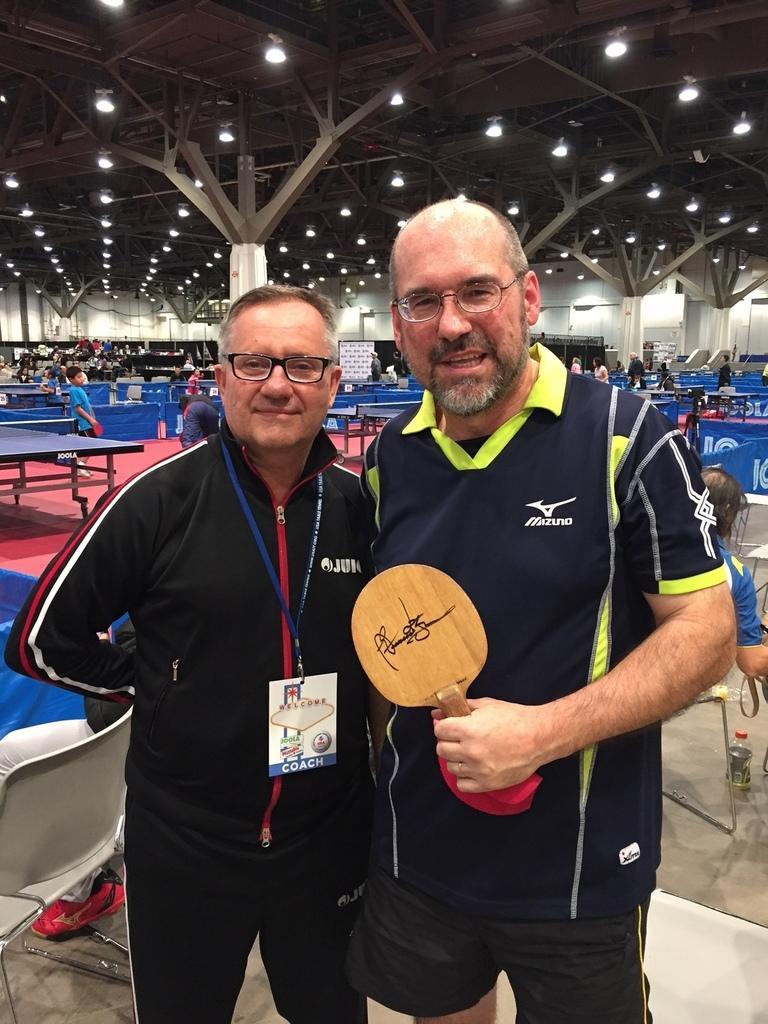Can you describe this image briefly? This picture shows two men standing here. One of the guys s holding a table tennis bat in his hand. Both of them were wearing spectacles. In the background, there are number of table tennis courts and some lights here. 